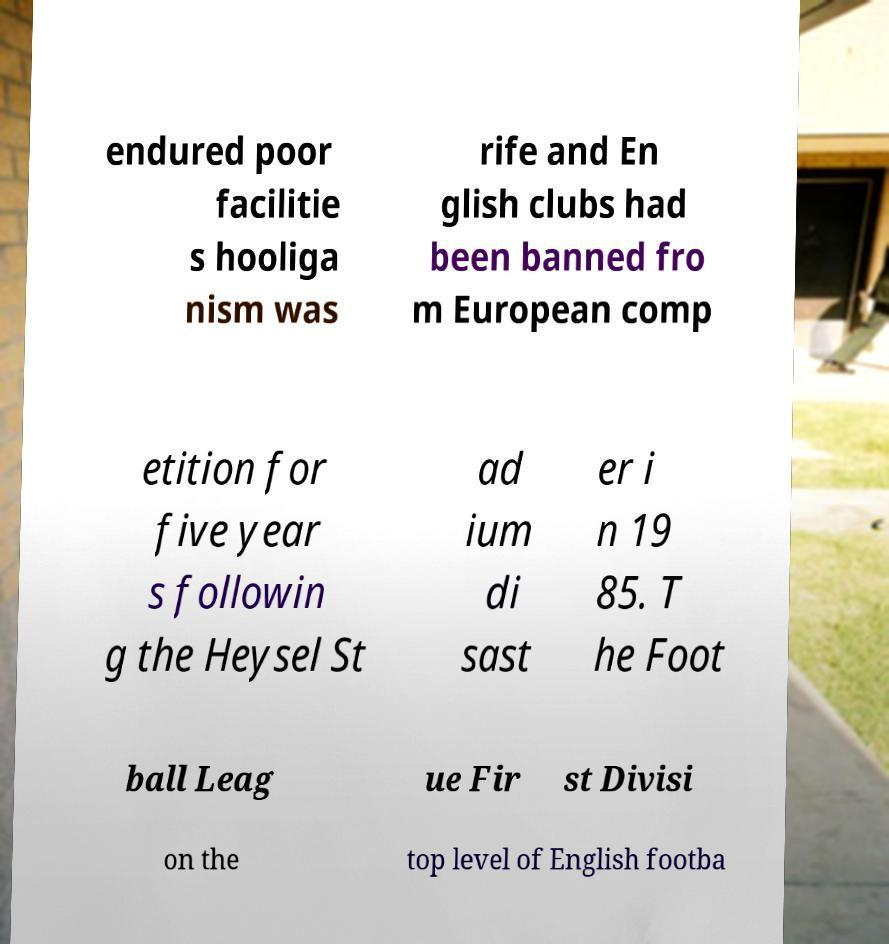Could you extract and type out the text from this image? endured poor facilitie s hooliga nism was rife and En glish clubs had been banned fro m European comp etition for five year s followin g the Heysel St ad ium di sast er i n 19 85. T he Foot ball Leag ue Fir st Divisi on the top level of English footba 